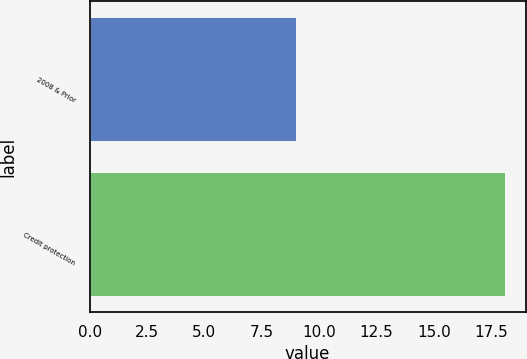Convert chart. <chart><loc_0><loc_0><loc_500><loc_500><bar_chart><fcel>2008 & Prior<fcel>Credit protection<nl><fcel>9<fcel>18.1<nl></chart> 